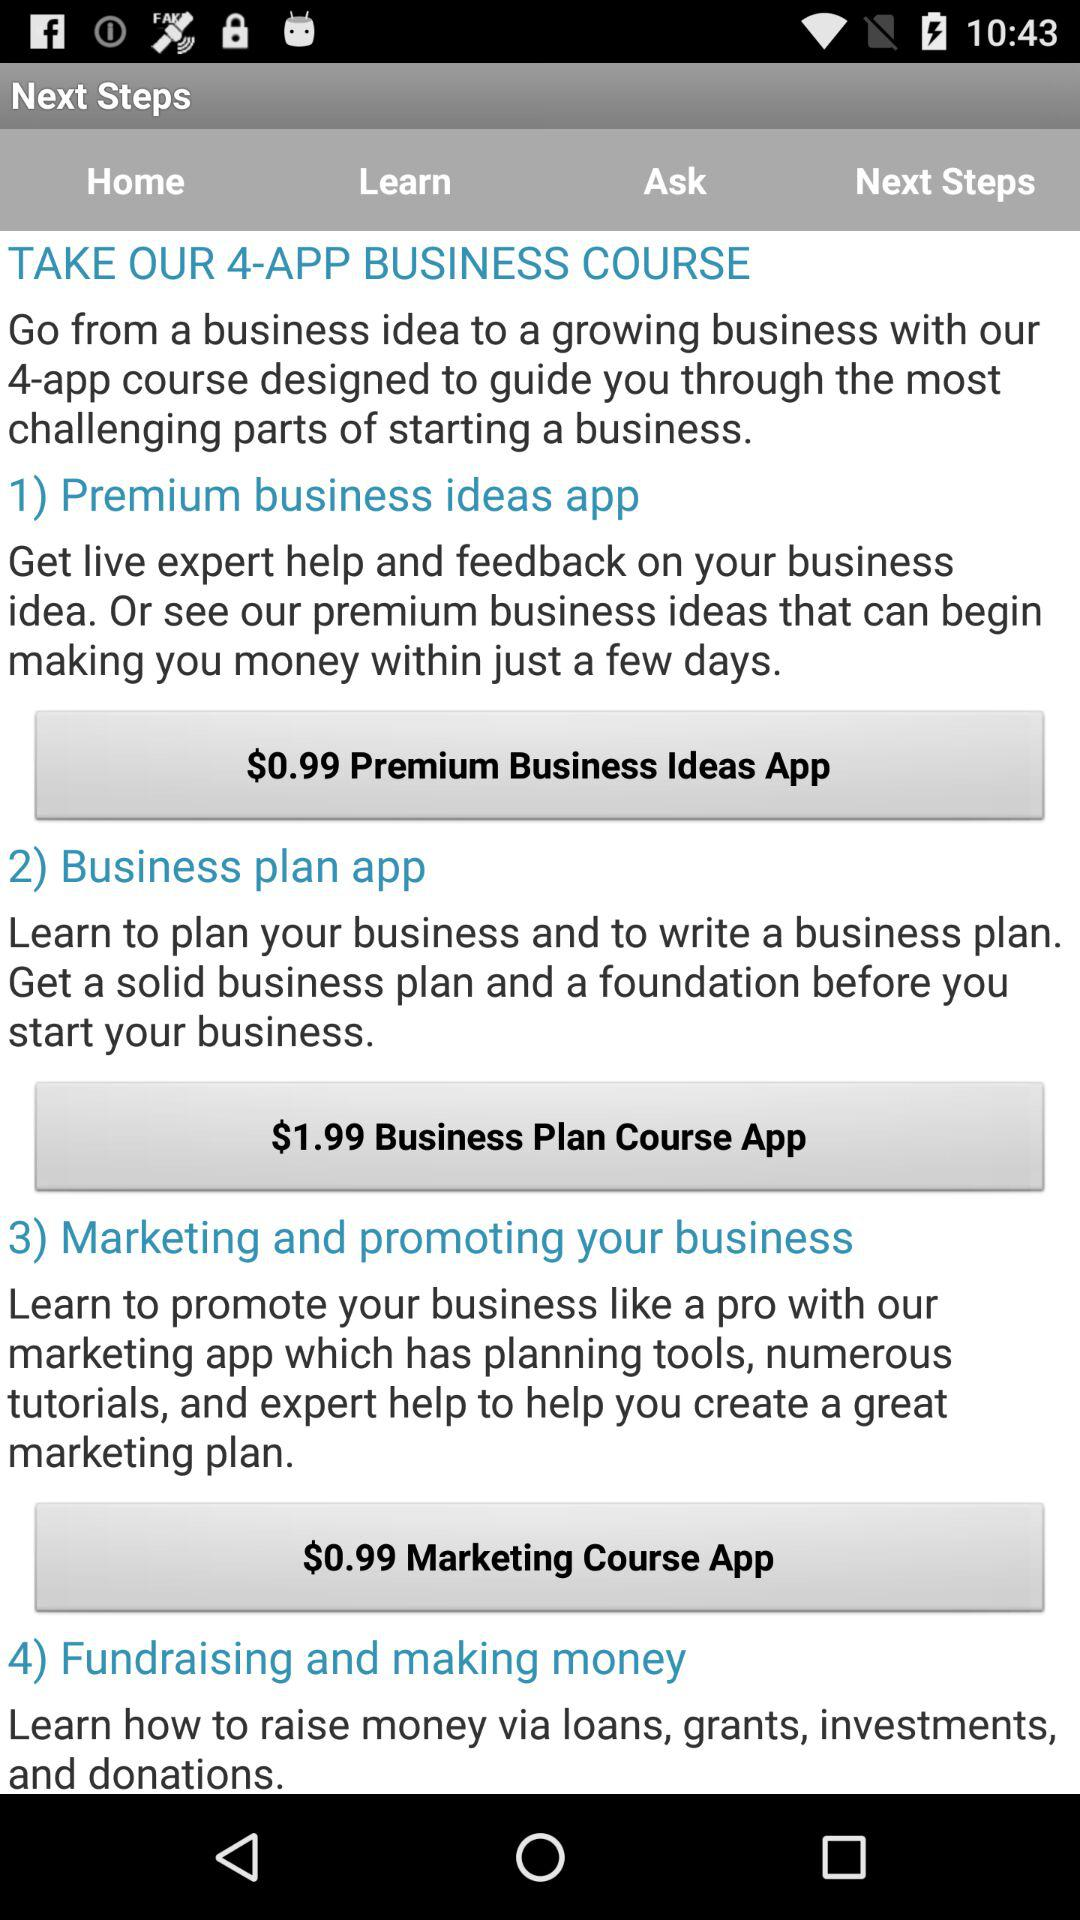What is the price of the "Marketing Course App"? The price of the "Marketing Course App" is $0.99. 